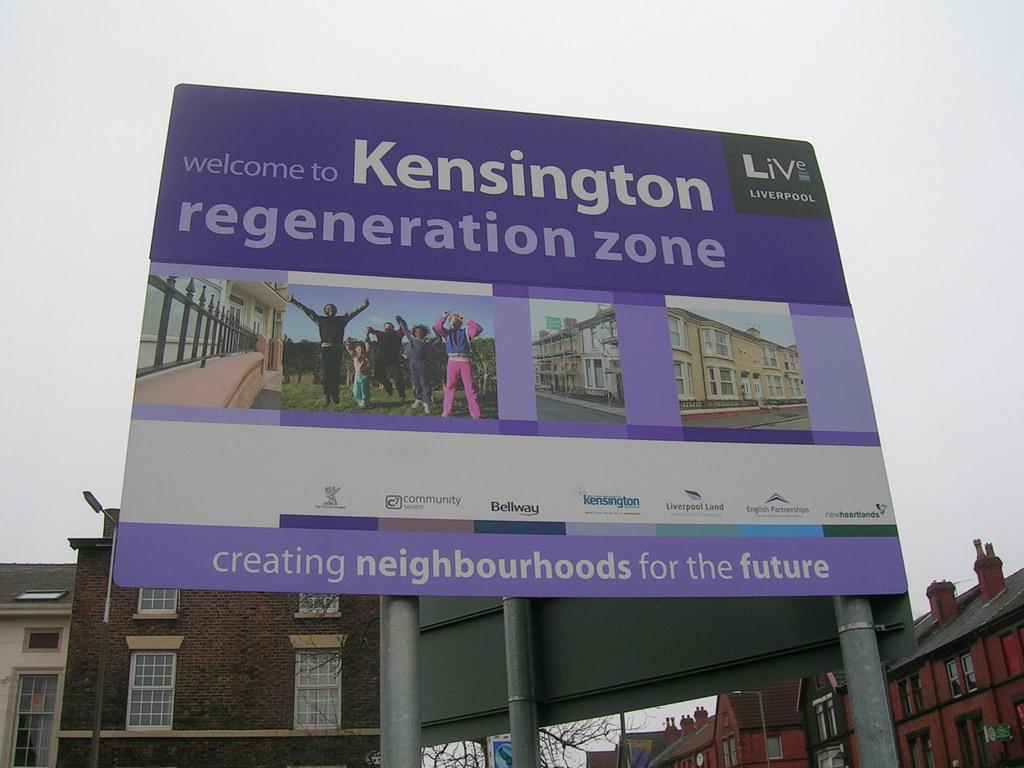What is the main subject in the image? There is a hoarding in the image. What else can be seen in the image besides the hoarding? Buildings are visible in the image. What is the condition of the sky in the image? Clouds are present in the sky in the image. What type of song can be heard playing from the carriage in the image? There is no carriage or song present in the image; it only features a hoarding and buildings. 